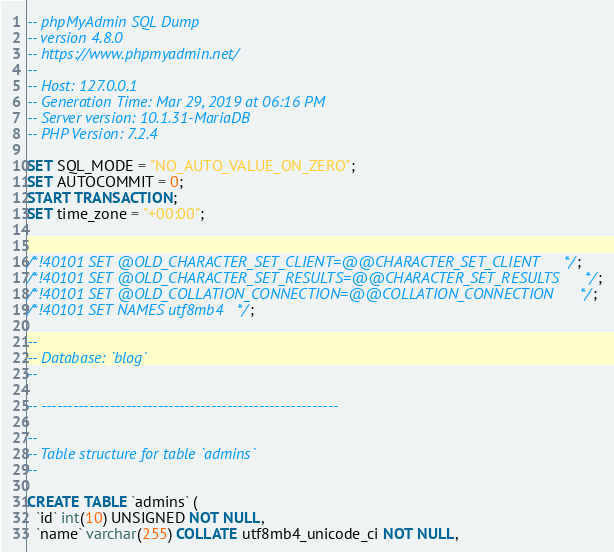<code> <loc_0><loc_0><loc_500><loc_500><_SQL_>-- phpMyAdmin SQL Dump
-- version 4.8.0
-- https://www.phpmyadmin.net/
--
-- Host: 127.0.0.1
-- Generation Time: Mar 29, 2019 at 06:16 PM
-- Server version: 10.1.31-MariaDB
-- PHP Version: 7.2.4

SET SQL_MODE = "NO_AUTO_VALUE_ON_ZERO";
SET AUTOCOMMIT = 0;
START TRANSACTION;
SET time_zone = "+00:00";


/*!40101 SET @OLD_CHARACTER_SET_CLIENT=@@CHARACTER_SET_CLIENT */;
/*!40101 SET @OLD_CHARACTER_SET_RESULTS=@@CHARACTER_SET_RESULTS */;
/*!40101 SET @OLD_COLLATION_CONNECTION=@@COLLATION_CONNECTION */;
/*!40101 SET NAMES utf8mb4 */;

--
-- Database: `blog`
--

-- --------------------------------------------------------

--
-- Table structure for table `admins`
--

CREATE TABLE `admins` (
  `id` int(10) UNSIGNED NOT NULL,
  `name` varchar(255) COLLATE utf8mb4_unicode_ci NOT NULL,</code> 